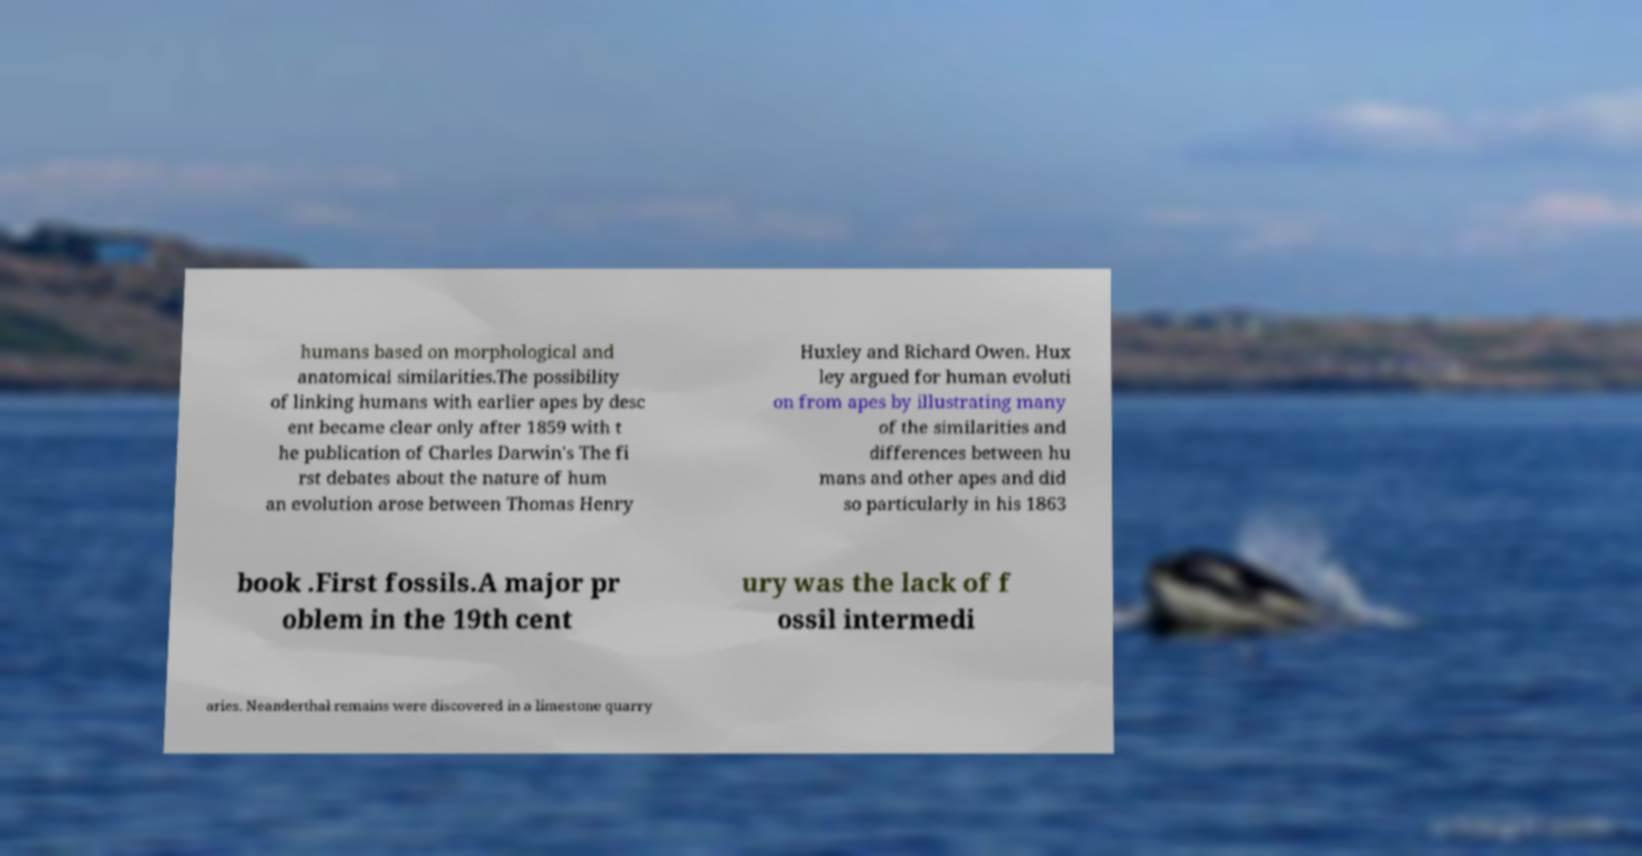I need the written content from this picture converted into text. Can you do that? humans based on morphological and anatomical similarities.The possibility of linking humans with earlier apes by desc ent became clear only after 1859 with t he publication of Charles Darwin's The fi rst debates about the nature of hum an evolution arose between Thomas Henry Huxley and Richard Owen. Hux ley argued for human evoluti on from apes by illustrating many of the similarities and differences between hu mans and other apes and did so particularly in his 1863 book .First fossils.A major pr oblem in the 19th cent ury was the lack of f ossil intermedi aries. Neanderthal remains were discovered in a limestone quarry 